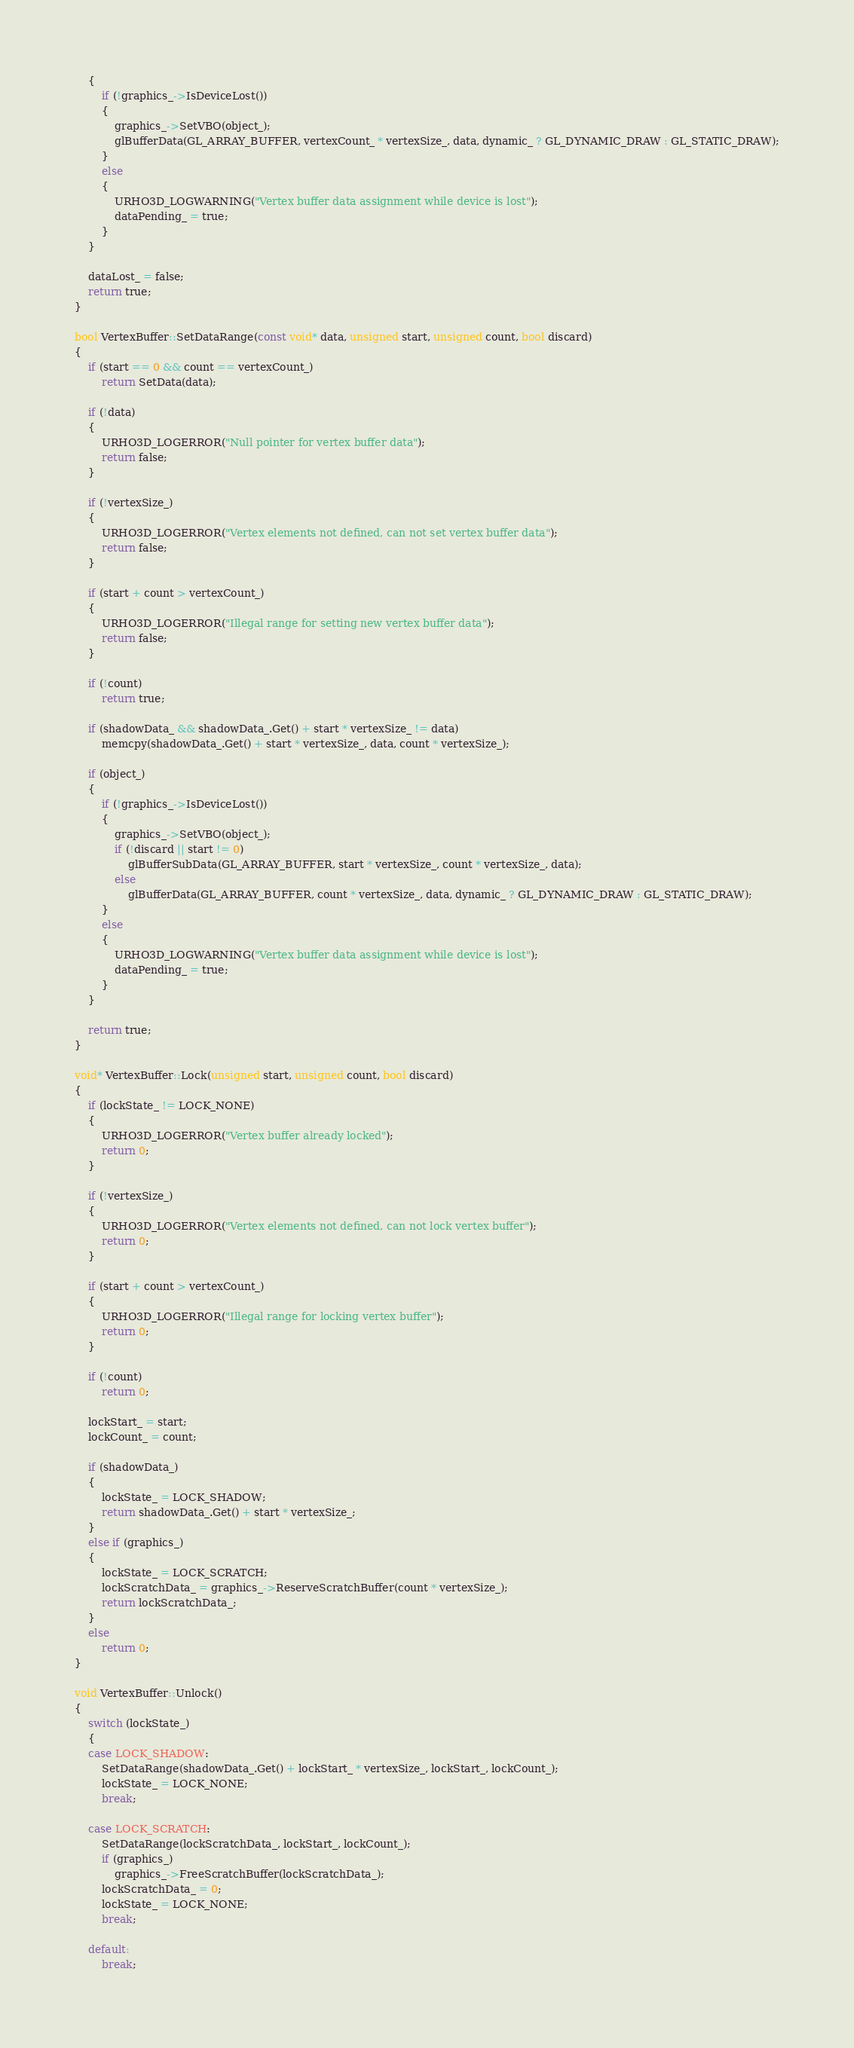Convert code to text. <code><loc_0><loc_0><loc_500><loc_500><_C++_>    {
        if (!graphics_->IsDeviceLost())
        {
            graphics_->SetVBO(object_);
            glBufferData(GL_ARRAY_BUFFER, vertexCount_ * vertexSize_, data, dynamic_ ? GL_DYNAMIC_DRAW : GL_STATIC_DRAW);
        }
        else
        {
            URHO3D_LOGWARNING("Vertex buffer data assignment while device is lost");
            dataPending_ = true;
        }
    }

    dataLost_ = false;
    return true;
}

bool VertexBuffer::SetDataRange(const void* data, unsigned start, unsigned count, bool discard)
{
    if (start == 0 && count == vertexCount_)
        return SetData(data);

    if (!data)
    {
        URHO3D_LOGERROR("Null pointer for vertex buffer data");
        return false;
    }

    if (!vertexSize_)
    {
        URHO3D_LOGERROR("Vertex elements not defined, can not set vertex buffer data");
        return false;
    }

    if (start + count > vertexCount_)
    {
        URHO3D_LOGERROR("Illegal range for setting new vertex buffer data");
        return false;
    }

    if (!count)
        return true;

    if (shadowData_ && shadowData_.Get() + start * vertexSize_ != data)
        memcpy(shadowData_.Get() + start * vertexSize_, data, count * vertexSize_);

    if (object_)
    {
        if (!graphics_->IsDeviceLost())
        {
            graphics_->SetVBO(object_);
            if (!discard || start != 0)
                glBufferSubData(GL_ARRAY_BUFFER, start * vertexSize_, count * vertexSize_, data);
            else
                glBufferData(GL_ARRAY_BUFFER, count * vertexSize_, data, dynamic_ ? GL_DYNAMIC_DRAW : GL_STATIC_DRAW);
        }
        else
        {
            URHO3D_LOGWARNING("Vertex buffer data assignment while device is lost");
            dataPending_ = true;
        }
    }

    return true;
}

void* VertexBuffer::Lock(unsigned start, unsigned count, bool discard)
{
    if (lockState_ != LOCK_NONE)
    {
        URHO3D_LOGERROR("Vertex buffer already locked");
        return 0;
    }

    if (!vertexSize_)
    {
        URHO3D_LOGERROR("Vertex elements not defined, can not lock vertex buffer");
        return 0;
    }

    if (start + count > vertexCount_)
    {
        URHO3D_LOGERROR("Illegal range for locking vertex buffer");
        return 0;
    }

    if (!count)
        return 0;

    lockStart_ = start;
    lockCount_ = count;

    if (shadowData_)
    {
        lockState_ = LOCK_SHADOW;
        return shadowData_.Get() + start * vertexSize_;
    }
    else if (graphics_)
    {
        lockState_ = LOCK_SCRATCH;
        lockScratchData_ = graphics_->ReserveScratchBuffer(count * vertexSize_);
        return lockScratchData_;
    }
    else
        return 0;
}

void VertexBuffer::Unlock()
{
    switch (lockState_)
    {
    case LOCK_SHADOW:
        SetDataRange(shadowData_.Get() + lockStart_ * vertexSize_, lockStart_, lockCount_);
        lockState_ = LOCK_NONE;
        break;

    case LOCK_SCRATCH:
        SetDataRange(lockScratchData_, lockStart_, lockCount_);
        if (graphics_)
            graphics_->FreeScratchBuffer(lockScratchData_);
        lockScratchData_ = 0;
        lockState_ = LOCK_NONE;
        break;

    default:
        break;</code> 